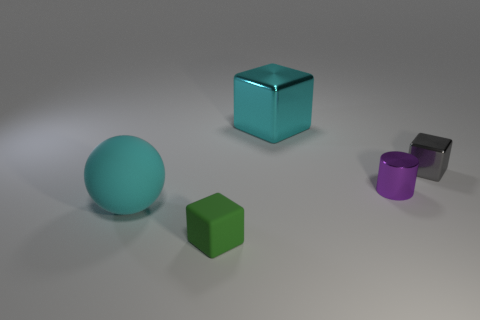How many other objects are the same shape as the big cyan metal object? 2 